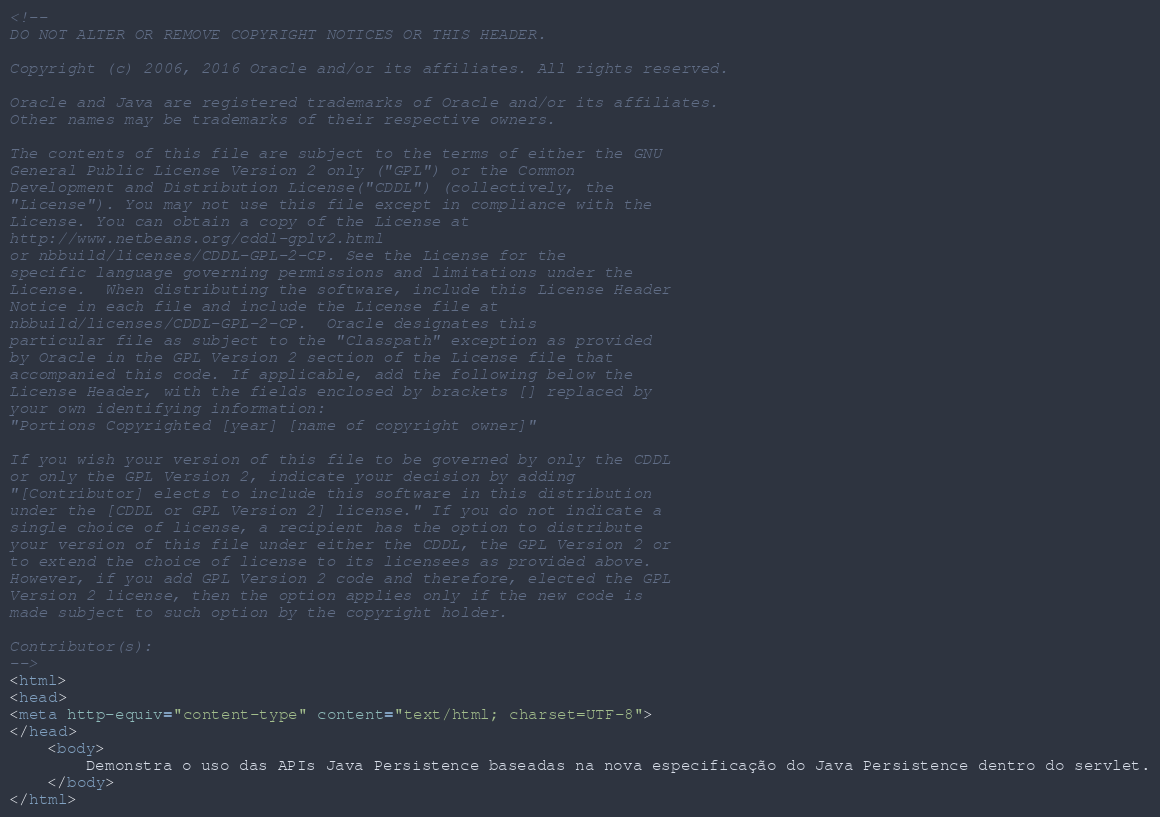Convert code to text. <code><loc_0><loc_0><loc_500><loc_500><_HTML_><!--
DO NOT ALTER OR REMOVE COPYRIGHT NOTICES OR THIS HEADER.

Copyright (c) 2006, 2016 Oracle and/or its affiliates. All rights reserved.

Oracle and Java are registered trademarks of Oracle and/or its affiliates.
Other names may be trademarks of their respective owners.

The contents of this file are subject to the terms of either the GNU
General Public License Version 2 only ("GPL") or the Common
Development and Distribution License("CDDL") (collectively, the
"License"). You may not use this file except in compliance with the
License. You can obtain a copy of the License at
http://www.netbeans.org/cddl-gplv2.html
or nbbuild/licenses/CDDL-GPL-2-CP. See the License for the
specific language governing permissions and limitations under the
License.  When distributing the software, include this License Header
Notice in each file and include the License file at
nbbuild/licenses/CDDL-GPL-2-CP.  Oracle designates this
particular file as subject to the "Classpath" exception as provided
by Oracle in the GPL Version 2 section of the License file that
accompanied this code. If applicable, add the following below the
License Header, with the fields enclosed by brackets [] replaced by
your own identifying information:
"Portions Copyrighted [year] [name of copyright owner]"

If you wish your version of this file to be governed by only the CDDL
or only the GPL Version 2, indicate your decision by adding
"[Contributor] elects to include this software in this distribution
under the [CDDL or GPL Version 2] license." If you do not indicate a
single choice of license, a recipient has the option to distribute
your version of this file under either the CDDL, the GPL Version 2 or
to extend the choice of license to its licensees as provided above.
However, if you add GPL Version 2 code and therefore, elected the GPL
Version 2 license, then the option applies only if the new code is
made subject to such option by the copyright holder.

Contributor(s):
-->
<html>
<head>
<meta http-equiv="content-type" content="text/html; charset=UTF-8">
</head>
    <body>
        Demonstra o uso das APIs Java Persistence baseadas na nova especificação do Java Persistence dentro do servlet.
    </body>
</html>
</code> 